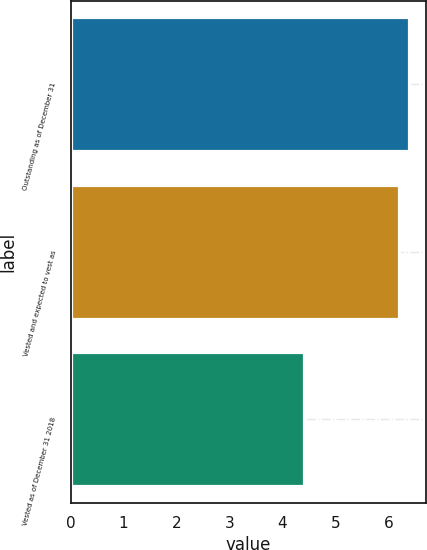Convert chart. <chart><loc_0><loc_0><loc_500><loc_500><bar_chart><fcel>Outstanding as of December 31<fcel>Vested and expected to vest as<fcel>Vested as of December 31 2018<nl><fcel>6.39<fcel>6.2<fcel>4.4<nl></chart> 